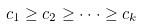<formula> <loc_0><loc_0><loc_500><loc_500>c _ { 1 } \geq c _ { 2 } \geq \cdot \cdot \cdot \geq c _ { k }</formula> 